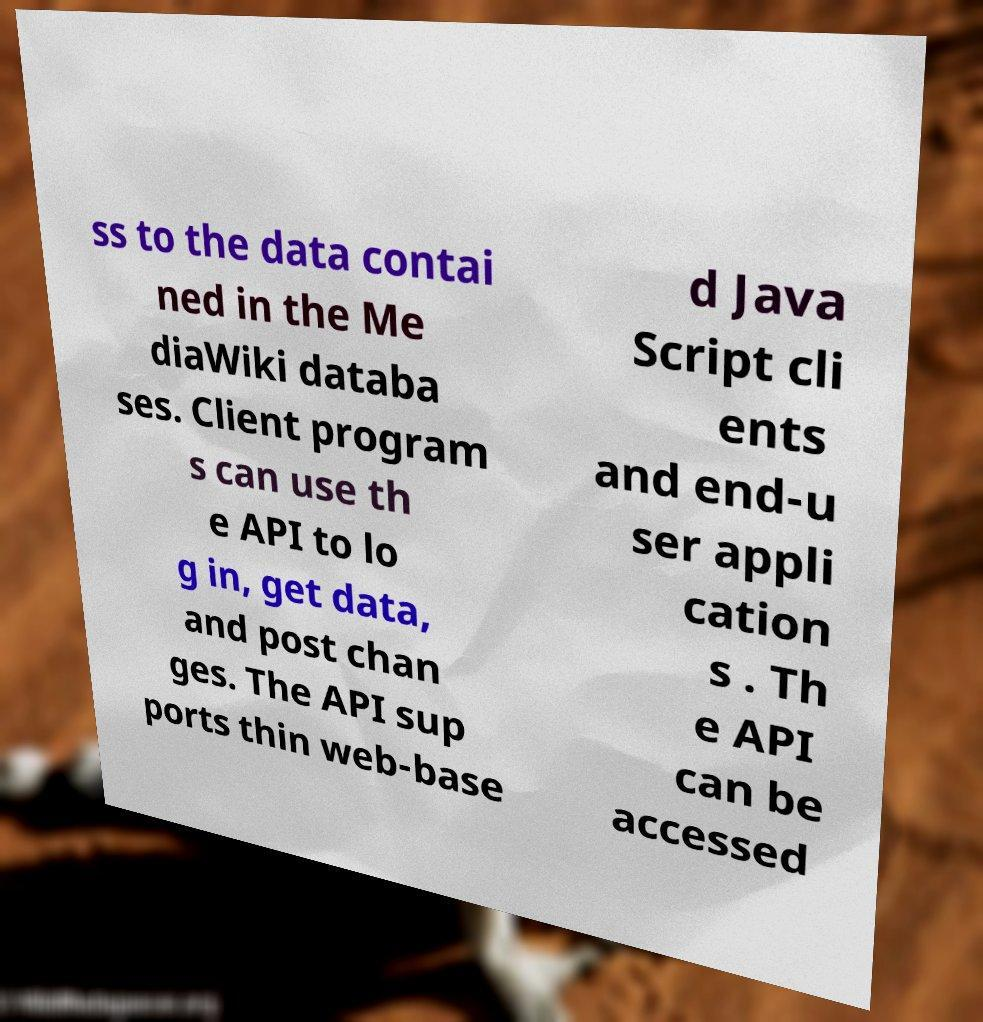Can you read and provide the text displayed in the image?This photo seems to have some interesting text. Can you extract and type it out for me? ss to the data contai ned in the Me diaWiki databa ses. Client program s can use th e API to lo g in, get data, and post chan ges. The API sup ports thin web-base d Java Script cli ents and end-u ser appli cation s . Th e API can be accessed 